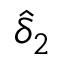Convert formula to latex. <formula><loc_0><loc_0><loc_500><loc_500>\hat { \delta } _ { 2 }</formula> 